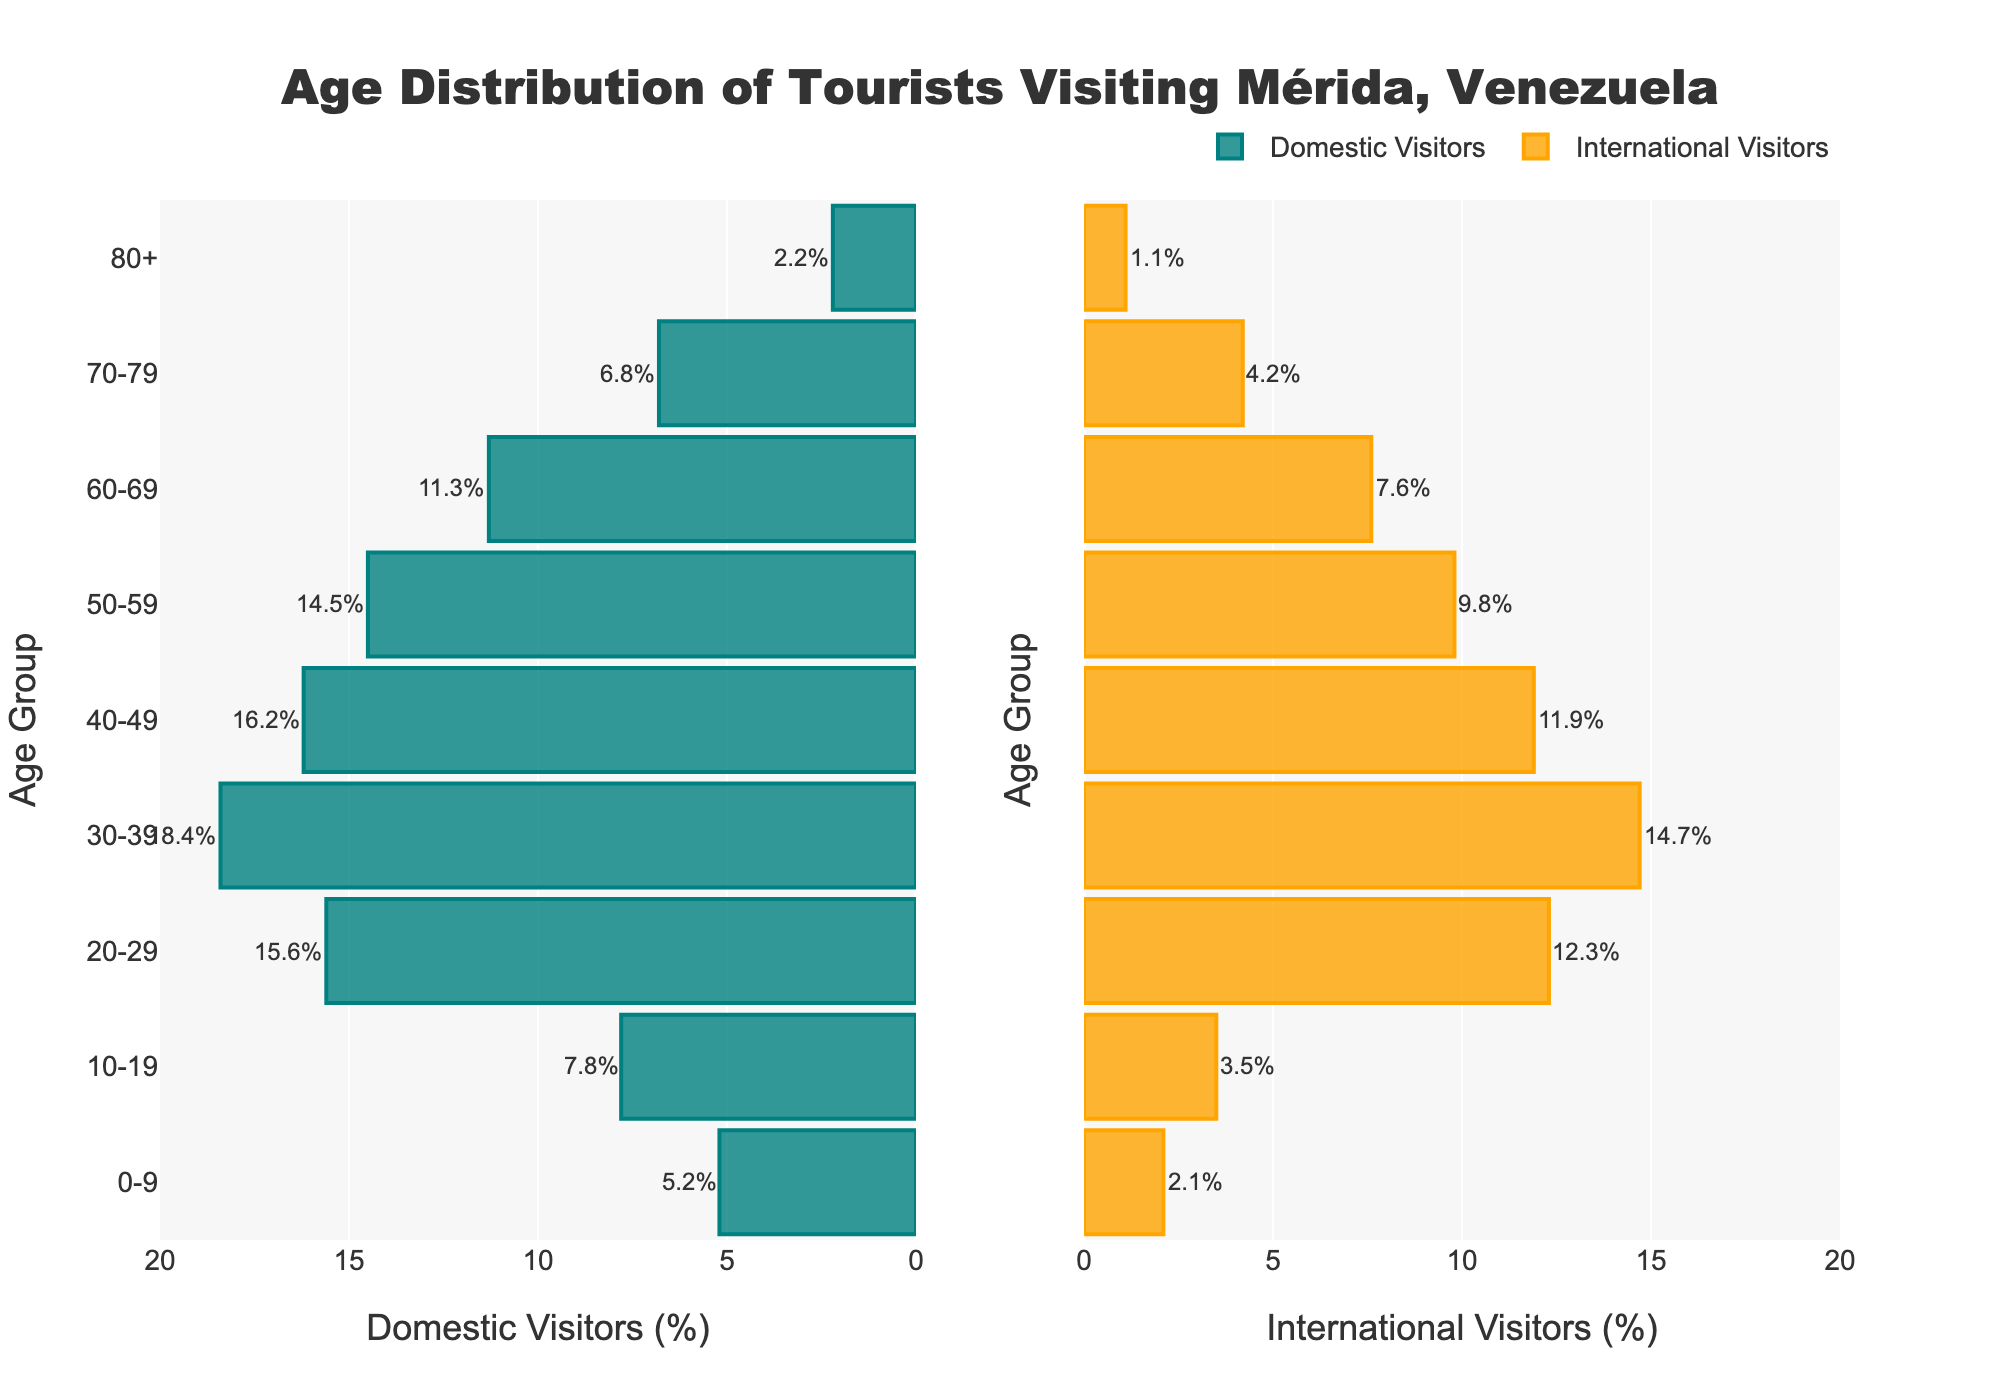What is the title of the figure? The title is typically displayed prominently at the top. For this figure, it states "Age Distribution of Tourists Visiting Mérida, Venezuela."
Answer: Age Distribution of Tourists Visiting Mérida, Venezuela How many age groups are displayed in the figure? Each bar represents an age group. Counting the number of bars on either side (since they match), we find there are 9 age groups.
Answer: 9 Which age group has the highest percentage of domestic visitors? Look at the left side (Domestic Visitors) and identify the bar with the greatest length. The age group 30-39 has the longest bar, which corresponds to 18.4%.
Answer: 30-39 Which age group has the lowest percentage of international visitors? On the right side (International Visitors), find the shortest bar. The 80+ age group has the shortest bar, at 1.1%.
Answer: 80+ How does the percentage of international visitors aged 20-29 compare to the same age group of domestic visitors? Compare the bars for the 20-29 age group: Domestic is 15.6% and International is 12.3%. 15.6% is greater than 12.3%.
Answer: Domestic visitors have a higher percentage What is the combined percentage of domestic and international visitors aged 40-49? Add both percentages for the 40-49 age group: Domestic (16.2%) + International (11.9%) = 28.1%.
Answer: 28.1% Which age group shows the greatest difference between domestic and international visitors, and what is that difference? Calculate the absolute differences for each age group and find the maximum value. The greatest difference is for the 30-39 age group: 18.4% - 14.7% = 3.7%.
Answer: 30-39, 3.7% What is the significance of the two different colors in the figure? The colors differentiate between Domestic Visitors (teal) and International Visitors (orange). Each side uses one color to represent one group.
Answer: Domestic Visitors and International Visitors Considering the age groups of 60-69 and 70-79, which group shows a higher percentage of visitors for both domestic and international categories? For the age group 60-69: 11.3% (Domestic) and 7.6% (International). For the age group 70-79: 6.8% (Domestic) and 4.2% (International). The 60-69 group shows higher percentages in both categories.
Answer: 60-69 for both What's the total percentage of international visitors aged below 30? Sum the percentages for the age groups 0-9, 10-19, and 20-29. 2.1% + 3.5% + 12.3% = 17.9%.
Answer: 17.9% 